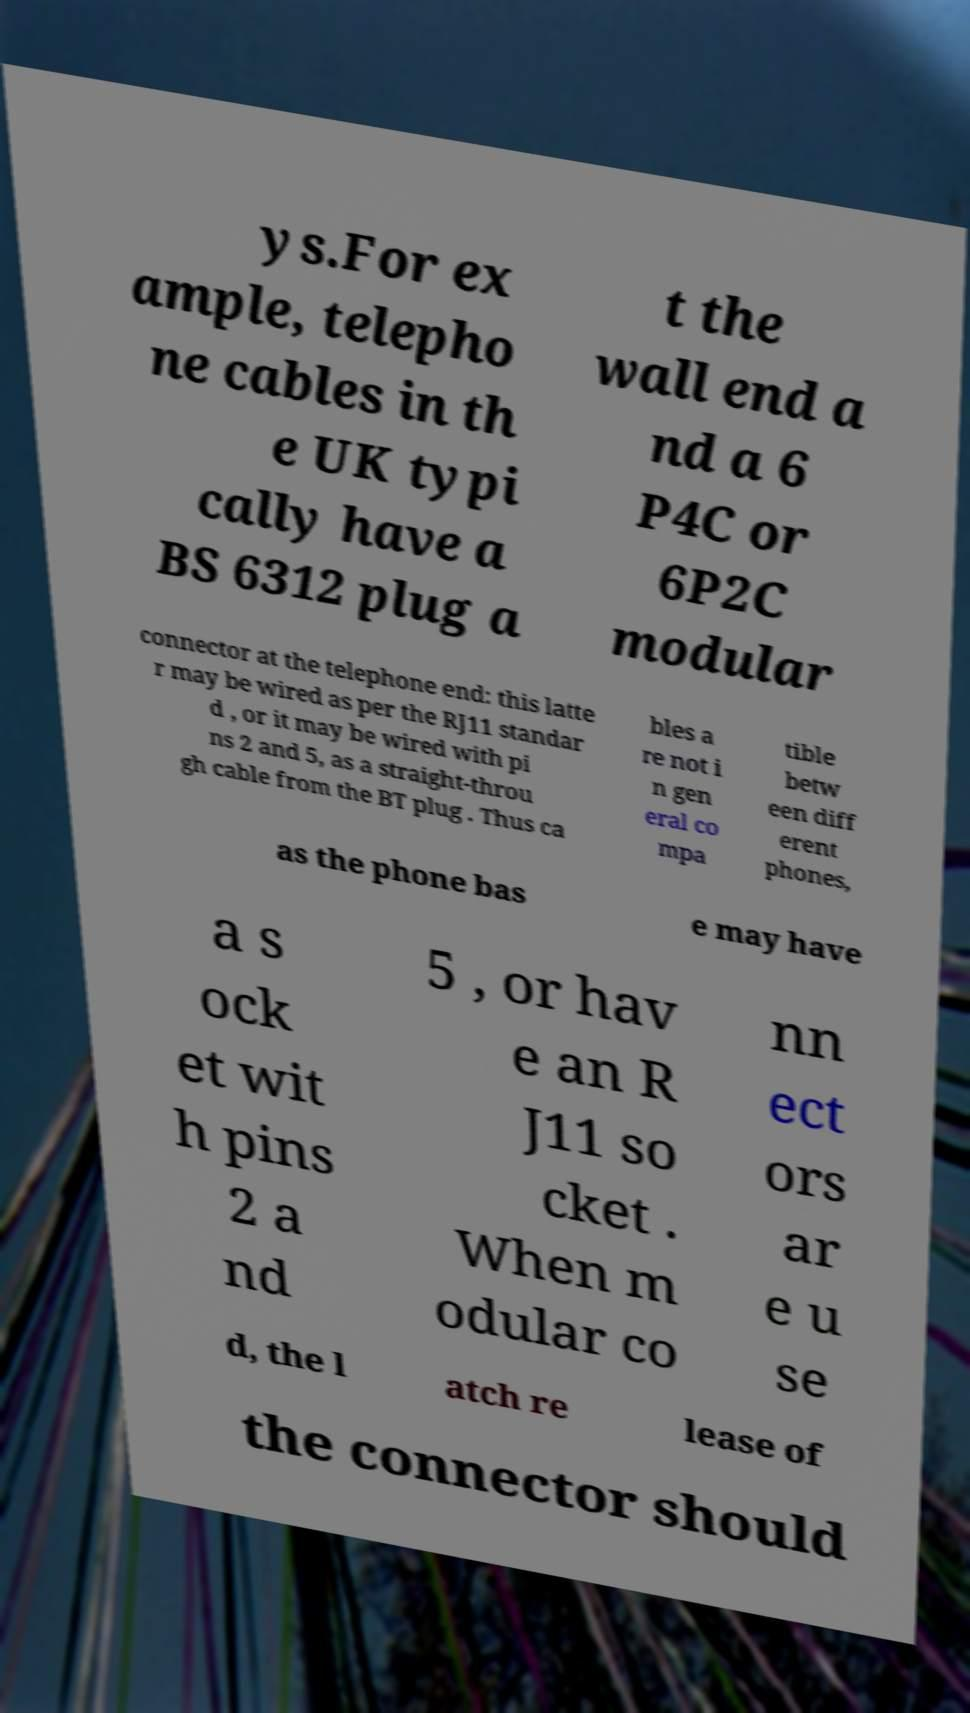Could you assist in decoding the text presented in this image and type it out clearly? ys.For ex ample, telepho ne cables in th e UK typi cally have a BS 6312 plug a t the wall end a nd a 6 P4C or 6P2C modular connector at the telephone end: this latte r may be wired as per the RJ11 standar d , or it may be wired with pi ns 2 and 5, as a straight-throu gh cable from the BT plug . Thus ca bles a re not i n gen eral co mpa tible betw een diff erent phones, as the phone bas e may have a s ock et wit h pins 2 a nd 5 , or hav e an R J11 so cket . When m odular co nn ect ors ar e u se d, the l atch re lease of the connector should 